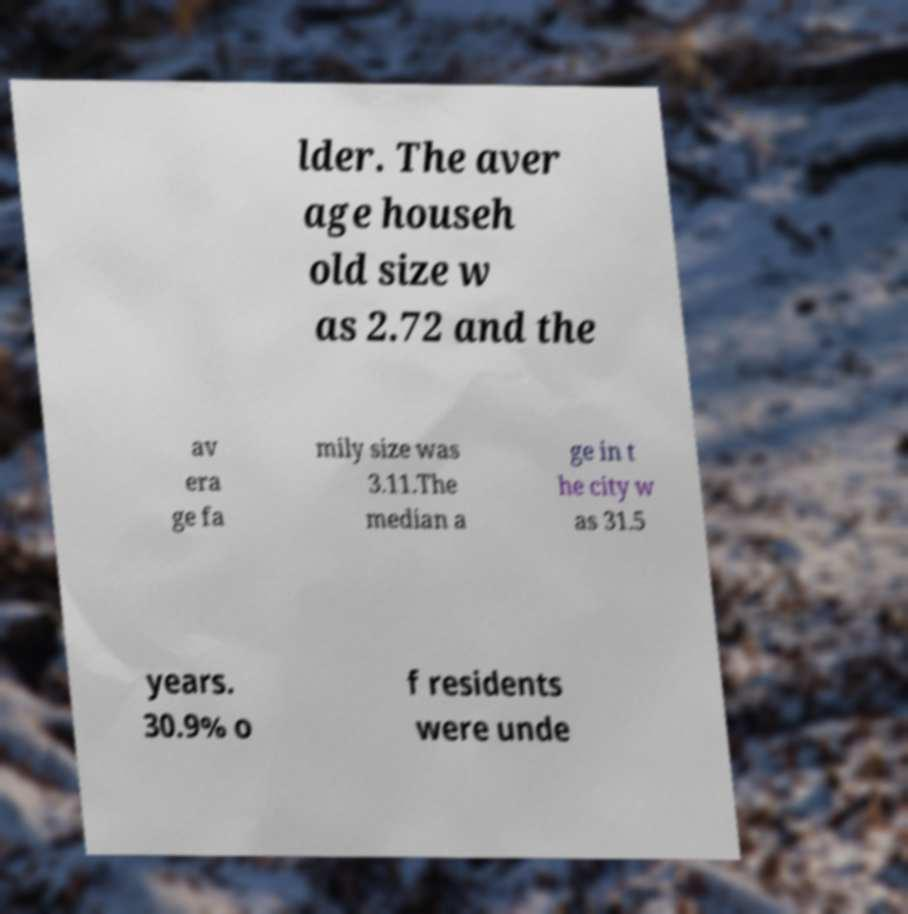Can you accurately transcribe the text from the provided image for me? lder. The aver age househ old size w as 2.72 and the av era ge fa mily size was 3.11.The median a ge in t he city w as 31.5 years. 30.9% o f residents were unde 